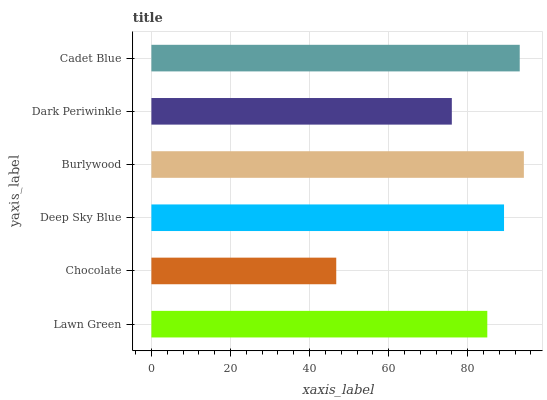Is Chocolate the minimum?
Answer yes or no. Yes. Is Burlywood the maximum?
Answer yes or no. Yes. Is Deep Sky Blue the minimum?
Answer yes or no. No. Is Deep Sky Blue the maximum?
Answer yes or no. No. Is Deep Sky Blue greater than Chocolate?
Answer yes or no. Yes. Is Chocolate less than Deep Sky Blue?
Answer yes or no. Yes. Is Chocolate greater than Deep Sky Blue?
Answer yes or no. No. Is Deep Sky Blue less than Chocolate?
Answer yes or no. No. Is Deep Sky Blue the high median?
Answer yes or no. Yes. Is Lawn Green the low median?
Answer yes or no. Yes. Is Dark Periwinkle the high median?
Answer yes or no. No. Is Chocolate the low median?
Answer yes or no. No. 